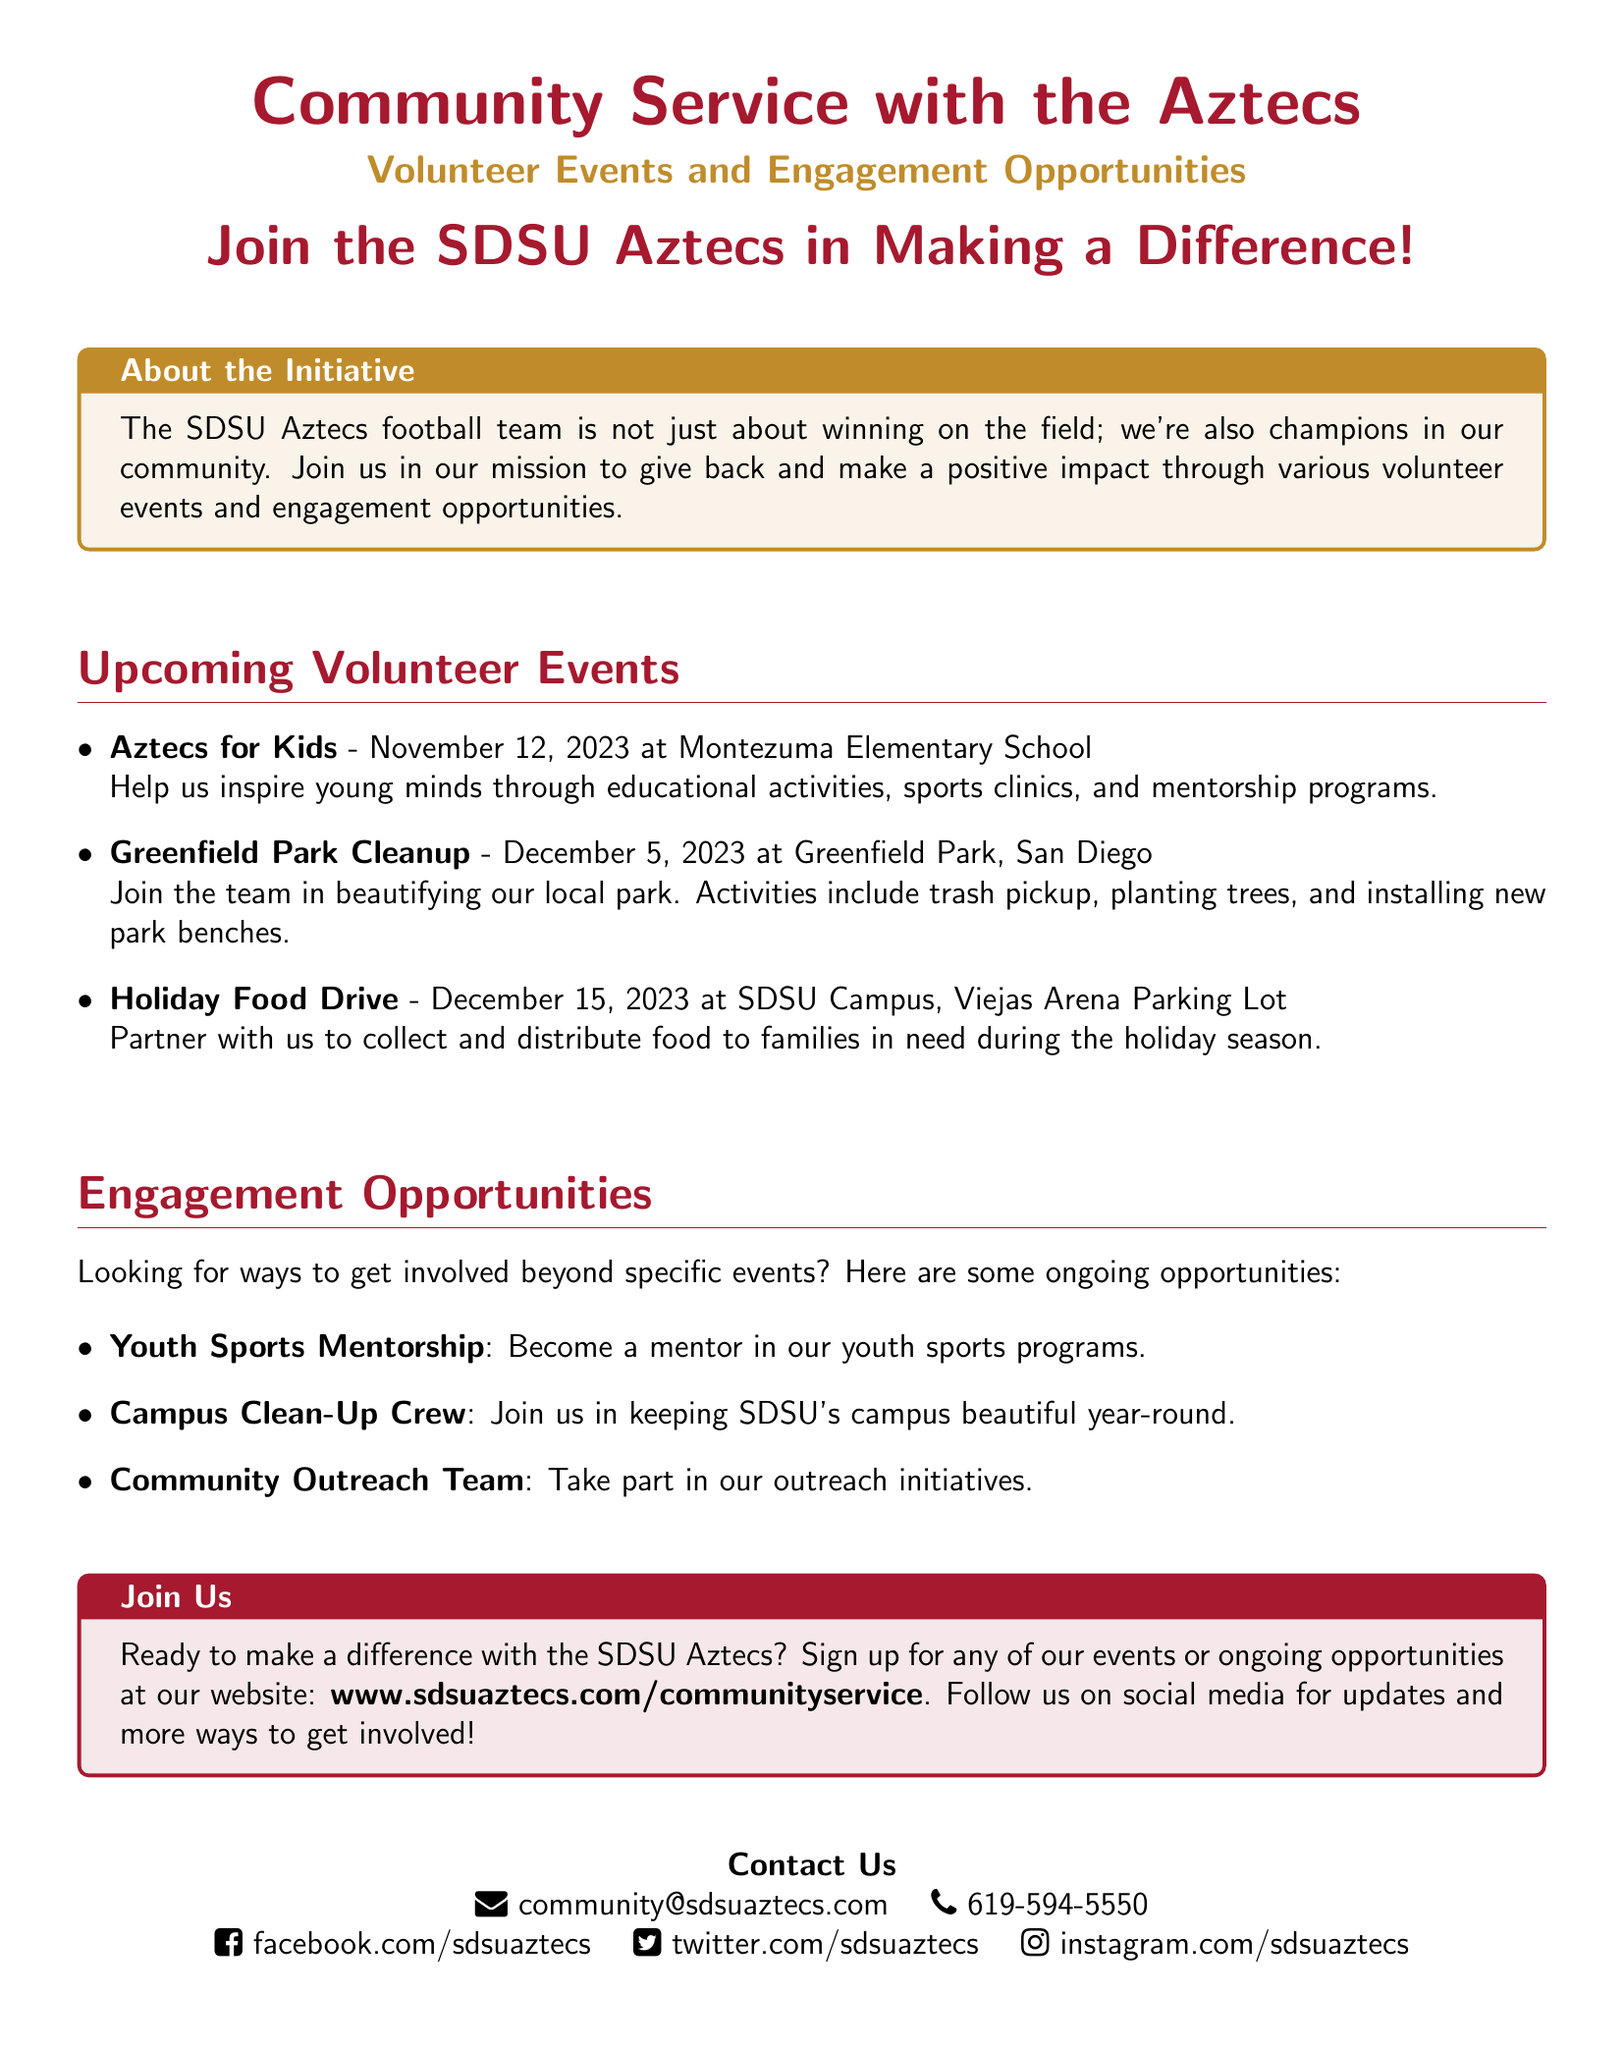What is the first volunteer event listed? The first volunteer event mentioned in the document is "Aztecs for Kids" scheduled for November 12, 2023.
Answer: Aztecs for Kids When is the Holiday Food Drive? The Holiday Food Drive is scheduled for December 15, 2023.
Answer: December 15, 2023 Where is the Greenfield Park Cleanup taking place? The cleanup event is occurring at Greenfield Park, San Diego.
Answer: Greenfield Park, San Diego What is one of the ongoing engagement opportunities? One ongoing engagement opportunity mentioned is "Youth Sports Mentorship."
Answer: Youth Sports Mentorship How can people sign up for events? Individuals can sign up for events through the SDSU Aztecs website provided in the document.
Answer: www.sdsuaztecs.com/communityservice What is the contact email provided in the document? The contact email for community service inquiries is "community@sdsuaztecs.com."
Answer: community@sdsuaztecs.com How many upcoming volunteer events are listed? There are three upcoming volunteer events listed in the document.
Answer: Three What color is used for the volunteer events title? The title for volunteer events is presented in Aztec gold color.
Answer: Aztec gold 